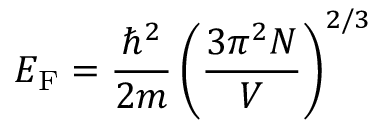Convert formula to latex. <formula><loc_0><loc_0><loc_500><loc_500>E _ { F } = { \frac { \hbar { ^ } { 2 } } { 2 m } } \left ( { \frac { 3 \pi ^ { 2 } N } { V } } \right ) ^ { 2 / 3 }</formula> 